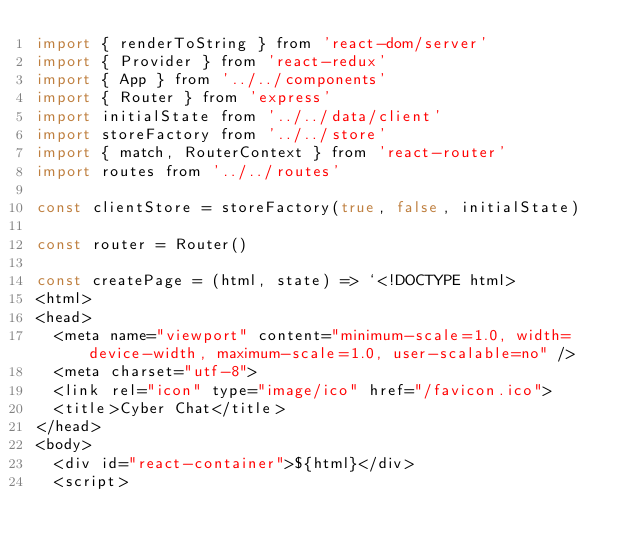Convert code to text. <code><loc_0><loc_0><loc_500><loc_500><_JavaScript_>import { renderToString } from 'react-dom/server'
import { Provider } from 'react-redux'
import { App } from '../../components'
import { Router } from 'express'
import initialState from '../../data/client'
import storeFactory from '../../store'
import { match, RouterContext } from 'react-router'
import routes from '../../routes'

const clientStore = storeFactory(true, false, initialState)

const router = Router()

const createPage = (html, state) => `<!DOCTYPE html>
<html>
<head>
  <meta name="viewport" content="minimum-scale=1.0, width=device-width, maximum-scale=1.0, user-scalable=no" />
  <meta charset="utf-8">
  <link rel="icon" type="image/ico" href="/favicon.ico">
  <title>Cyber Chat</title>
</head>
<body>
  <div id="react-container">${html}</div>
  <script></code> 